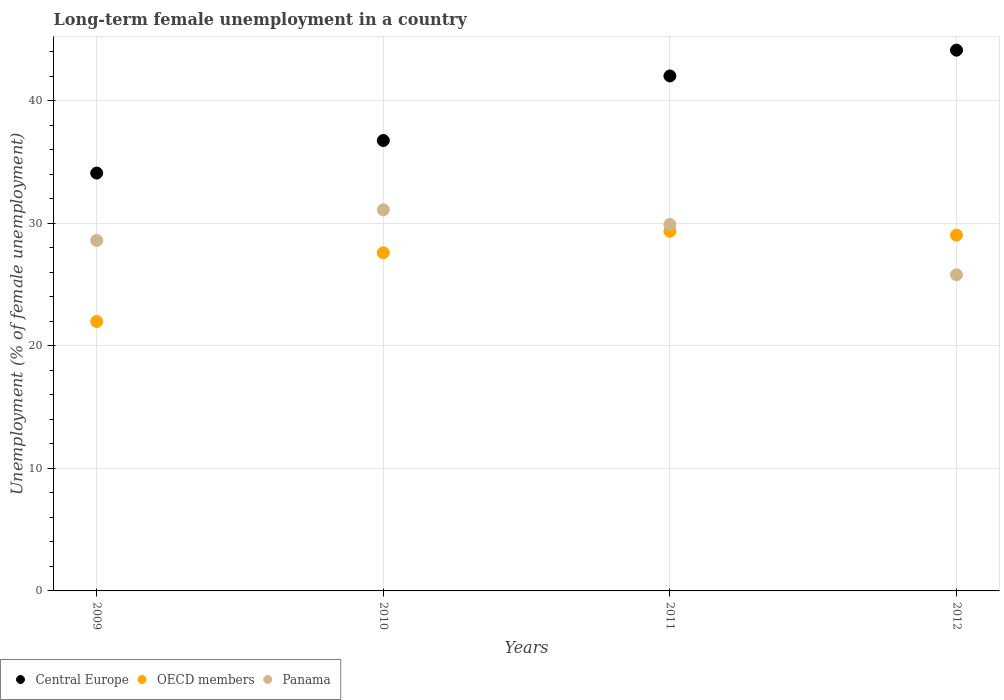How many different coloured dotlines are there?
Your response must be concise. 3. Is the number of dotlines equal to the number of legend labels?
Your response must be concise. Yes. What is the percentage of long-term unemployed female population in Panama in 2011?
Your answer should be compact. 29.9. Across all years, what is the maximum percentage of long-term unemployed female population in OECD members?
Make the answer very short. 29.35. Across all years, what is the minimum percentage of long-term unemployed female population in Central Europe?
Make the answer very short. 34.1. In which year was the percentage of long-term unemployed female population in Central Europe maximum?
Offer a very short reply. 2012. What is the total percentage of long-term unemployed female population in OECD members in the graph?
Provide a succinct answer. 107.95. What is the difference between the percentage of long-term unemployed female population in Central Europe in 2009 and that in 2010?
Offer a terse response. -2.66. What is the difference between the percentage of long-term unemployed female population in Central Europe in 2010 and the percentage of long-term unemployed female population in Panama in 2009?
Keep it short and to the point. 8.15. What is the average percentage of long-term unemployed female population in Panama per year?
Your answer should be compact. 28.85. In the year 2010, what is the difference between the percentage of long-term unemployed female population in Central Europe and percentage of long-term unemployed female population in OECD members?
Provide a short and direct response. 9.16. What is the ratio of the percentage of long-term unemployed female population in Central Europe in 2009 to that in 2011?
Offer a very short reply. 0.81. Is the percentage of long-term unemployed female population in OECD members in 2009 less than that in 2012?
Offer a terse response. Yes. Is the difference between the percentage of long-term unemployed female population in Central Europe in 2009 and 2012 greater than the difference between the percentage of long-term unemployed female population in OECD members in 2009 and 2012?
Ensure brevity in your answer.  No. What is the difference between the highest and the second highest percentage of long-term unemployed female population in Panama?
Ensure brevity in your answer.  1.2. What is the difference between the highest and the lowest percentage of long-term unemployed female population in OECD members?
Your answer should be compact. 7.36. Is the sum of the percentage of long-term unemployed female population in Central Europe in 2009 and 2011 greater than the maximum percentage of long-term unemployed female population in OECD members across all years?
Your answer should be very brief. Yes. Is it the case that in every year, the sum of the percentage of long-term unemployed female population in Panama and percentage of long-term unemployed female population in OECD members  is greater than the percentage of long-term unemployed female population in Central Europe?
Give a very brief answer. Yes. Is the percentage of long-term unemployed female population in OECD members strictly greater than the percentage of long-term unemployed female population in Panama over the years?
Offer a terse response. No. Is the percentage of long-term unemployed female population in Central Europe strictly less than the percentage of long-term unemployed female population in Panama over the years?
Offer a terse response. No. How many years are there in the graph?
Provide a succinct answer. 4. What is the difference between two consecutive major ticks on the Y-axis?
Offer a very short reply. 10. What is the title of the graph?
Give a very brief answer. Long-term female unemployment in a country. What is the label or title of the X-axis?
Keep it short and to the point. Years. What is the label or title of the Y-axis?
Offer a very short reply. Unemployment (% of female unemployment). What is the Unemployment (% of female unemployment) in Central Europe in 2009?
Your answer should be very brief. 34.1. What is the Unemployment (% of female unemployment) in OECD members in 2009?
Provide a succinct answer. 21.98. What is the Unemployment (% of female unemployment) of Panama in 2009?
Offer a terse response. 28.6. What is the Unemployment (% of female unemployment) of Central Europe in 2010?
Provide a short and direct response. 36.75. What is the Unemployment (% of female unemployment) of OECD members in 2010?
Your answer should be very brief. 27.59. What is the Unemployment (% of female unemployment) of Panama in 2010?
Ensure brevity in your answer.  31.1. What is the Unemployment (% of female unemployment) in Central Europe in 2011?
Give a very brief answer. 42.02. What is the Unemployment (% of female unemployment) in OECD members in 2011?
Make the answer very short. 29.35. What is the Unemployment (% of female unemployment) of Panama in 2011?
Your answer should be compact. 29.9. What is the Unemployment (% of female unemployment) in Central Europe in 2012?
Offer a terse response. 44.13. What is the Unemployment (% of female unemployment) of OECD members in 2012?
Your answer should be compact. 29.03. What is the Unemployment (% of female unemployment) of Panama in 2012?
Provide a succinct answer. 25.8. Across all years, what is the maximum Unemployment (% of female unemployment) of Central Europe?
Offer a very short reply. 44.13. Across all years, what is the maximum Unemployment (% of female unemployment) of OECD members?
Your response must be concise. 29.35. Across all years, what is the maximum Unemployment (% of female unemployment) in Panama?
Offer a terse response. 31.1. Across all years, what is the minimum Unemployment (% of female unemployment) of Central Europe?
Ensure brevity in your answer.  34.1. Across all years, what is the minimum Unemployment (% of female unemployment) of OECD members?
Your response must be concise. 21.98. Across all years, what is the minimum Unemployment (% of female unemployment) of Panama?
Keep it short and to the point. 25.8. What is the total Unemployment (% of female unemployment) of Central Europe in the graph?
Make the answer very short. 157. What is the total Unemployment (% of female unemployment) in OECD members in the graph?
Your answer should be compact. 107.95. What is the total Unemployment (% of female unemployment) of Panama in the graph?
Provide a succinct answer. 115.4. What is the difference between the Unemployment (% of female unemployment) in Central Europe in 2009 and that in 2010?
Offer a very short reply. -2.66. What is the difference between the Unemployment (% of female unemployment) in OECD members in 2009 and that in 2010?
Offer a very short reply. -5.61. What is the difference between the Unemployment (% of female unemployment) in Panama in 2009 and that in 2010?
Keep it short and to the point. -2.5. What is the difference between the Unemployment (% of female unemployment) in Central Europe in 2009 and that in 2011?
Your response must be concise. -7.93. What is the difference between the Unemployment (% of female unemployment) of OECD members in 2009 and that in 2011?
Make the answer very short. -7.36. What is the difference between the Unemployment (% of female unemployment) of Panama in 2009 and that in 2011?
Offer a terse response. -1.3. What is the difference between the Unemployment (% of female unemployment) in Central Europe in 2009 and that in 2012?
Provide a short and direct response. -10.03. What is the difference between the Unemployment (% of female unemployment) in OECD members in 2009 and that in 2012?
Offer a very short reply. -7.05. What is the difference between the Unemployment (% of female unemployment) in Panama in 2009 and that in 2012?
Ensure brevity in your answer.  2.8. What is the difference between the Unemployment (% of female unemployment) of Central Europe in 2010 and that in 2011?
Give a very brief answer. -5.27. What is the difference between the Unemployment (% of female unemployment) in OECD members in 2010 and that in 2011?
Give a very brief answer. -1.75. What is the difference between the Unemployment (% of female unemployment) in Central Europe in 2010 and that in 2012?
Your answer should be very brief. -7.37. What is the difference between the Unemployment (% of female unemployment) in OECD members in 2010 and that in 2012?
Your answer should be very brief. -1.44. What is the difference between the Unemployment (% of female unemployment) in Central Europe in 2011 and that in 2012?
Offer a terse response. -2.1. What is the difference between the Unemployment (% of female unemployment) of OECD members in 2011 and that in 2012?
Your response must be concise. 0.32. What is the difference between the Unemployment (% of female unemployment) in Central Europe in 2009 and the Unemployment (% of female unemployment) in OECD members in 2010?
Give a very brief answer. 6.51. What is the difference between the Unemployment (% of female unemployment) of Central Europe in 2009 and the Unemployment (% of female unemployment) of Panama in 2010?
Provide a succinct answer. 3. What is the difference between the Unemployment (% of female unemployment) of OECD members in 2009 and the Unemployment (% of female unemployment) of Panama in 2010?
Offer a very short reply. -9.12. What is the difference between the Unemployment (% of female unemployment) in Central Europe in 2009 and the Unemployment (% of female unemployment) in OECD members in 2011?
Offer a very short reply. 4.75. What is the difference between the Unemployment (% of female unemployment) in Central Europe in 2009 and the Unemployment (% of female unemployment) in Panama in 2011?
Give a very brief answer. 4.2. What is the difference between the Unemployment (% of female unemployment) in OECD members in 2009 and the Unemployment (% of female unemployment) in Panama in 2011?
Give a very brief answer. -7.92. What is the difference between the Unemployment (% of female unemployment) of Central Europe in 2009 and the Unemployment (% of female unemployment) of OECD members in 2012?
Provide a short and direct response. 5.07. What is the difference between the Unemployment (% of female unemployment) in Central Europe in 2009 and the Unemployment (% of female unemployment) in Panama in 2012?
Your answer should be very brief. 8.3. What is the difference between the Unemployment (% of female unemployment) of OECD members in 2009 and the Unemployment (% of female unemployment) of Panama in 2012?
Offer a terse response. -3.82. What is the difference between the Unemployment (% of female unemployment) of Central Europe in 2010 and the Unemployment (% of female unemployment) of OECD members in 2011?
Provide a succinct answer. 7.41. What is the difference between the Unemployment (% of female unemployment) of Central Europe in 2010 and the Unemployment (% of female unemployment) of Panama in 2011?
Provide a short and direct response. 6.85. What is the difference between the Unemployment (% of female unemployment) of OECD members in 2010 and the Unemployment (% of female unemployment) of Panama in 2011?
Your response must be concise. -2.31. What is the difference between the Unemployment (% of female unemployment) in Central Europe in 2010 and the Unemployment (% of female unemployment) in OECD members in 2012?
Your response must be concise. 7.72. What is the difference between the Unemployment (% of female unemployment) in Central Europe in 2010 and the Unemployment (% of female unemployment) in Panama in 2012?
Ensure brevity in your answer.  10.95. What is the difference between the Unemployment (% of female unemployment) of OECD members in 2010 and the Unemployment (% of female unemployment) of Panama in 2012?
Make the answer very short. 1.79. What is the difference between the Unemployment (% of female unemployment) in Central Europe in 2011 and the Unemployment (% of female unemployment) in OECD members in 2012?
Make the answer very short. 12.99. What is the difference between the Unemployment (% of female unemployment) of Central Europe in 2011 and the Unemployment (% of female unemployment) of Panama in 2012?
Your answer should be compact. 16.22. What is the difference between the Unemployment (% of female unemployment) in OECD members in 2011 and the Unemployment (% of female unemployment) in Panama in 2012?
Keep it short and to the point. 3.55. What is the average Unemployment (% of female unemployment) of Central Europe per year?
Give a very brief answer. 39.25. What is the average Unemployment (% of female unemployment) in OECD members per year?
Your response must be concise. 26.99. What is the average Unemployment (% of female unemployment) in Panama per year?
Provide a succinct answer. 28.85. In the year 2009, what is the difference between the Unemployment (% of female unemployment) in Central Europe and Unemployment (% of female unemployment) in OECD members?
Offer a very short reply. 12.11. In the year 2009, what is the difference between the Unemployment (% of female unemployment) in Central Europe and Unemployment (% of female unemployment) in Panama?
Give a very brief answer. 5.5. In the year 2009, what is the difference between the Unemployment (% of female unemployment) of OECD members and Unemployment (% of female unemployment) of Panama?
Ensure brevity in your answer.  -6.62. In the year 2010, what is the difference between the Unemployment (% of female unemployment) in Central Europe and Unemployment (% of female unemployment) in OECD members?
Provide a short and direct response. 9.16. In the year 2010, what is the difference between the Unemployment (% of female unemployment) of Central Europe and Unemployment (% of female unemployment) of Panama?
Give a very brief answer. 5.65. In the year 2010, what is the difference between the Unemployment (% of female unemployment) of OECD members and Unemployment (% of female unemployment) of Panama?
Your answer should be compact. -3.51. In the year 2011, what is the difference between the Unemployment (% of female unemployment) in Central Europe and Unemployment (% of female unemployment) in OECD members?
Keep it short and to the point. 12.68. In the year 2011, what is the difference between the Unemployment (% of female unemployment) of Central Europe and Unemployment (% of female unemployment) of Panama?
Give a very brief answer. 12.12. In the year 2011, what is the difference between the Unemployment (% of female unemployment) in OECD members and Unemployment (% of female unemployment) in Panama?
Make the answer very short. -0.55. In the year 2012, what is the difference between the Unemployment (% of female unemployment) of Central Europe and Unemployment (% of female unemployment) of OECD members?
Your answer should be very brief. 15.1. In the year 2012, what is the difference between the Unemployment (% of female unemployment) of Central Europe and Unemployment (% of female unemployment) of Panama?
Make the answer very short. 18.33. In the year 2012, what is the difference between the Unemployment (% of female unemployment) in OECD members and Unemployment (% of female unemployment) in Panama?
Ensure brevity in your answer.  3.23. What is the ratio of the Unemployment (% of female unemployment) in Central Europe in 2009 to that in 2010?
Your answer should be very brief. 0.93. What is the ratio of the Unemployment (% of female unemployment) in OECD members in 2009 to that in 2010?
Your answer should be compact. 0.8. What is the ratio of the Unemployment (% of female unemployment) in Panama in 2009 to that in 2010?
Offer a terse response. 0.92. What is the ratio of the Unemployment (% of female unemployment) of Central Europe in 2009 to that in 2011?
Ensure brevity in your answer.  0.81. What is the ratio of the Unemployment (% of female unemployment) of OECD members in 2009 to that in 2011?
Provide a short and direct response. 0.75. What is the ratio of the Unemployment (% of female unemployment) of Panama in 2009 to that in 2011?
Offer a terse response. 0.96. What is the ratio of the Unemployment (% of female unemployment) of Central Europe in 2009 to that in 2012?
Keep it short and to the point. 0.77. What is the ratio of the Unemployment (% of female unemployment) in OECD members in 2009 to that in 2012?
Offer a terse response. 0.76. What is the ratio of the Unemployment (% of female unemployment) of Panama in 2009 to that in 2012?
Give a very brief answer. 1.11. What is the ratio of the Unemployment (% of female unemployment) of Central Europe in 2010 to that in 2011?
Your response must be concise. 0.87. What is the ratio of the Unemployment (% of female unemployment) of OECD members in 2010 to that in 2011?
Keep it short and to the point. 0.94. What is the ratio of the Unemployment (% of female unemployment) of Panama in 2010 to that in 2011?
Give a very brief answer. 1.04. What is the ratio of the Unemployment (% of female unemployment) in Central Europe in 2010 to that in 2012?
Provide a short and direct response. 0.83. What is the ratio of the Unemployment (% of female unemployment) in OECD members in 2010 to that in 2012?
Your answer should be very brief. 0.95. What is the ratio of the Unemployment (% of female unemployment) of Panama in 2010 to that in 2012?
Offer a terse response. 1.21. What is the ratio of the Unemployment (% of female unemployment) of Central Europe in 2011 to that in 2012?
Your answer should be very brief. 0.95. What is the ratio of the Unemployment (% of female unemployment) of OECD members in 2011 to that in 2012?
Provide a short and direct response. 1.01. What is the ratio of the Unemployment (% of female unemployment) of Panama in 2011 to that in 2012?
Provide a succinct answer. 1.16. What is the difference between the highest and the second highest Unemployment (% of female unemployment) of Central Europe?
Your answer should be compact. 2.1. What is the difference between the highest and the second highest Unemployment (% of female unemployment) of OECD members?
Your answer should be compact. 0.32. What is the difference between the highest and the second highest Unemployment (% of female unemployment) in Panama?
Provide a succinct answer. 1.2. What is the difference between the highest and the lowest Unemployment (% of female unemployment) in Central Europe?
Your answer should be compact. 10.03. What is the difference between the highest and the lowest Unemployment (% of female unemployment) of OECD members?
Offer a very short reply. 7.36. What is the difference between the highest and the lowest Unemployment (% of female unemployment) of Panama?
Keep it short and to the point. 5.3. 